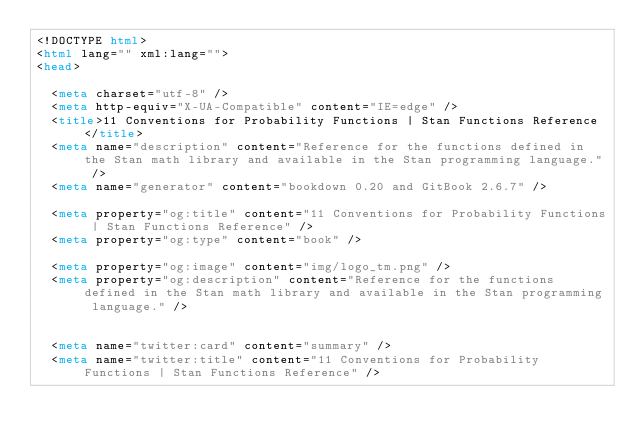Convert code to text. <code><loc_0><loc_0><loc_500><loc_500><_HTML_><!DOCTYPE html>
<html lang="" xml:lang="">
<head>

  <meta charset="utf-8" />
  <meta http-equiv="X-UA-Compatible" content="IE=edge" />
  <title>11 Conventions for Probability Functions | Stan Functions Reference</title>
  <meta name="description" content="Reference for the functions defined in the Stan math library and available in the Stan programming language." />
  <meta name="generator" content="bookdown 0.20 and GitBook 2.6.7" />

  <meta property="og:title" content="11 Conventions for Probability Functions | Stan Functions Reference" />
  <meta property="og:type" content="book" />
  
  <meta property="og:image" content="img/logo_tm.png" />
  <meta property="og:description" content="Reference for the functions defined in the Stan math library and available in the Stan programming language." />
  

  <meta name="twitter:card" content="summary" />
  <meta name="twitter:title" content="11 Conventions for Probability Functions | Stan Functions Reference" />
  </code> 